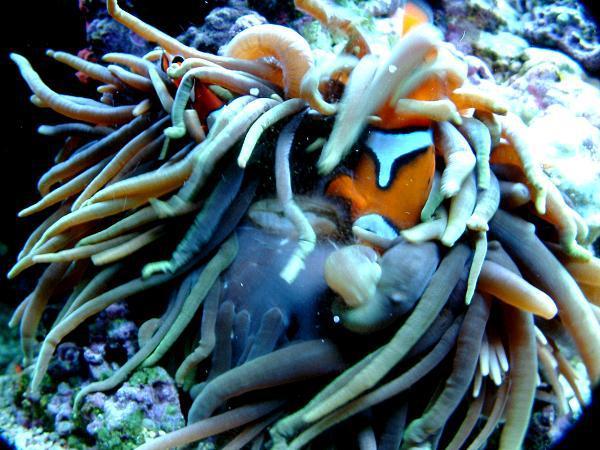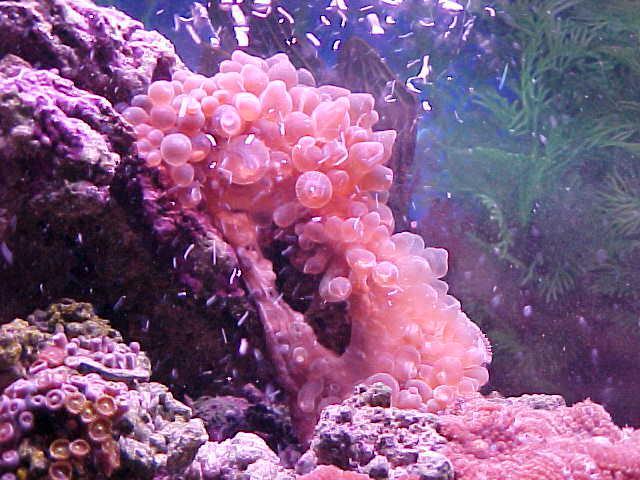The first image is the image on the left, the second image is the image on the right. Considering the images on both sides, is "In at least one image there is a single  pink corral reef with and open oval circle in the middle of the reef facing up." valid? Answer yes or no. Yes. The first image is the image on the left, the second image is the image on the right. Considering the images on both sides, is "One image shows anemone with bulbous pink tendrils, and the other image includes orange-and-white clownfish colors by anemone tendrils." valid? Answer yes or no. Yes. 